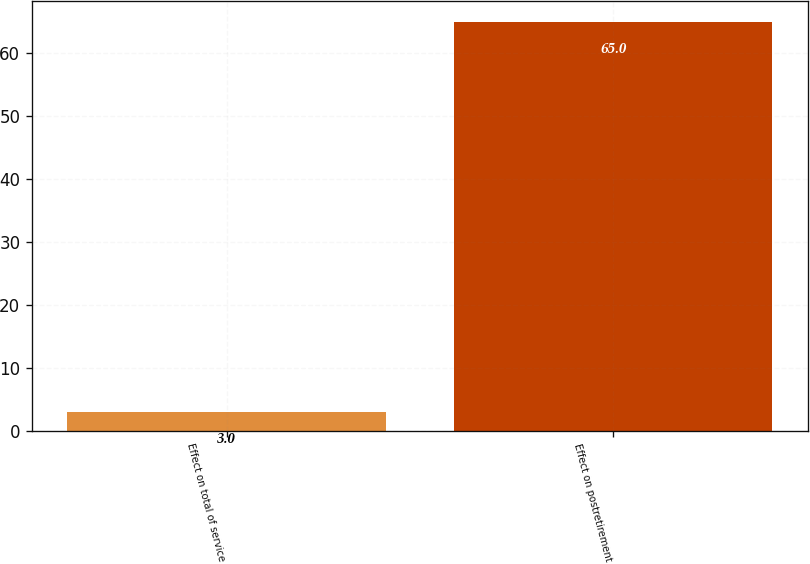Convert chart to OTSL. <chart><loc_0><loc_0><loc_500><loc_500><bar_chart><fcel>Effect on total of service<fcel>Effect on postretirement<nl><fcel>3<fcel>65<nl></chart> 